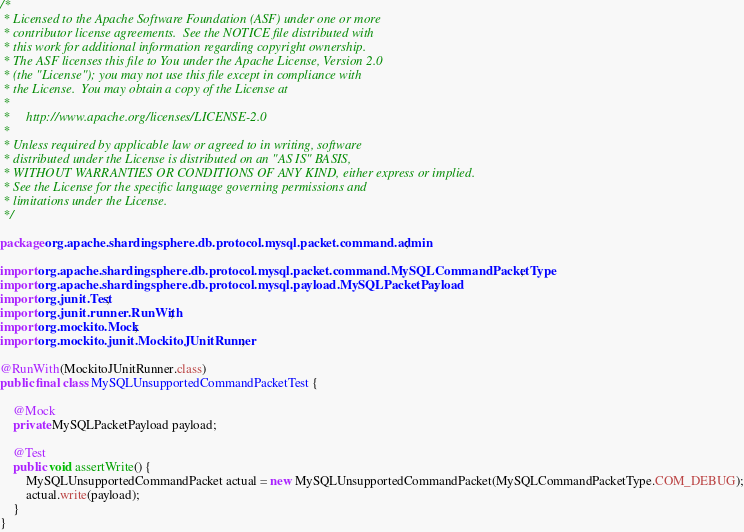<code> <loc_0><loc_0><loc_500><loc_500><_Java_>/*
 * Licensed to the Apache Software Foundation (ASF) under one or more
 * contributor license agreements.  See the NOTICE file distributed with
 * this work for additional information regarding copyright ownership.
 * The ASF licenses this file to You under the Apache License, Version 2.0
 * (the "License"); you may not use this file except in compliance with
 * the License.  You may obtain a copy of the License at
 *
 *     http://www.apache.org/licenses/LICENSE-2.0
 *
 * Unless required by applicable law or agreed to in writing, software
 * distributed under the License is distributed on an "AS IS" BASIS,
 * WITHOUT WARRANTIES OR CONDITIONS OF ANY KIND, either express or implied.
 * See the License for the specific language governing permissions and
 * limitations under the License.
 */

package org.apache.shardingsphere.db.protocol.mysql.packet.command.admin;

import org.apache.shardingsphere.db.protocol.mysql.packet.command.MySQLCommandPacketType;
import org.apache.shardingsphere.db.protocol.mysql.payload.MySQLPacketPayload;
import org.junit.Test;
import org.junit.runner.RunWith;
import org.mockito.Mock;
import org.mockito.junit.MockitoJUnitRunner;

@RunWith(MockitoJUnitRunner.class)
public final class MySQLUnsupportedCommandPacketTest {
    
    @Mock
    private MySQLPacketPayload payload;
    
    @Test
    public void assertWrite() {
        MySQLUnsupportedCommandPacket actual = new MySQLUnsupportedCommandPacket(MySQLCommandPacketType.COM_DEBUG);
        actual.write(payload);
    }
}
</code> 